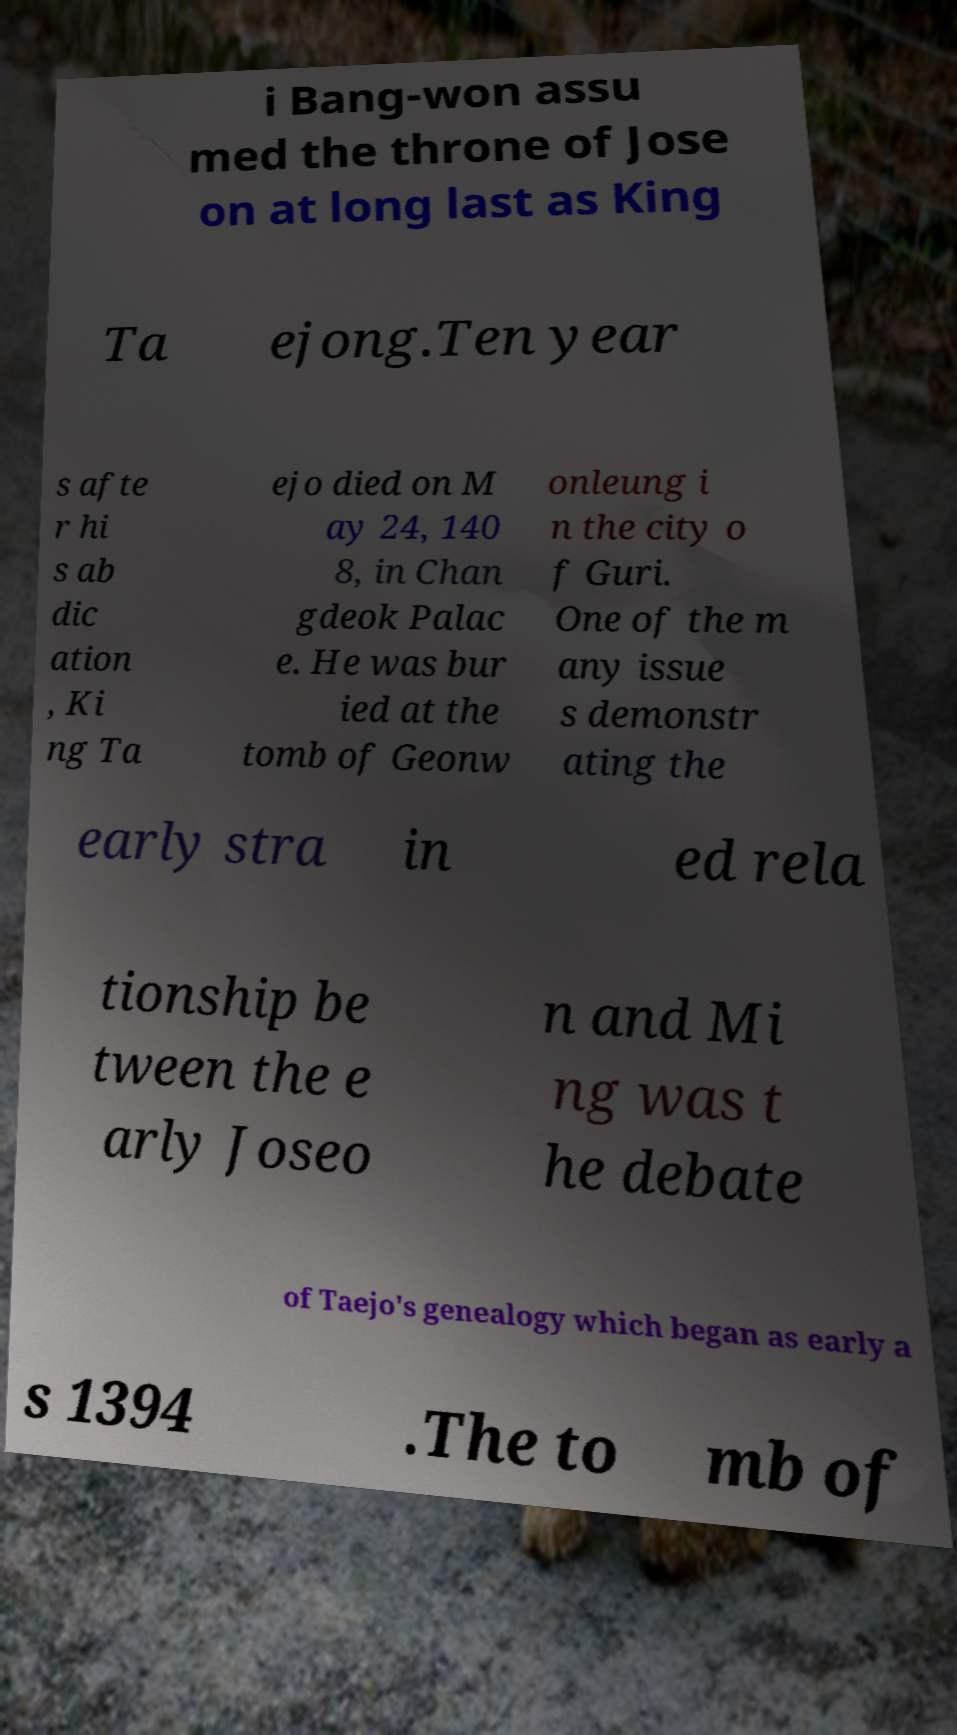Please read and relay the text visible in this image. What does it say? i Bang-won assu med the throne of Jose on at long last as King Ta ejong.Ten year s afte r hi s ab dic ation , Ki ng Ta ejo died on M ay 24, 140 8, in Chan gdeok Palac e. He was bur ied at the tomb of Geonw onleung i n the city o f Guri. One of the m any issue s demonstr ating the early stra in ed rela tionship be tween the e arly Joseo n and Mi ng was t he debate of Taejo's genealogy which began as early a s 1394 .The to mb of 